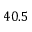<formula> <loc_0><loc_0><loc_500><loc_500>4 0 . 5</formula> 